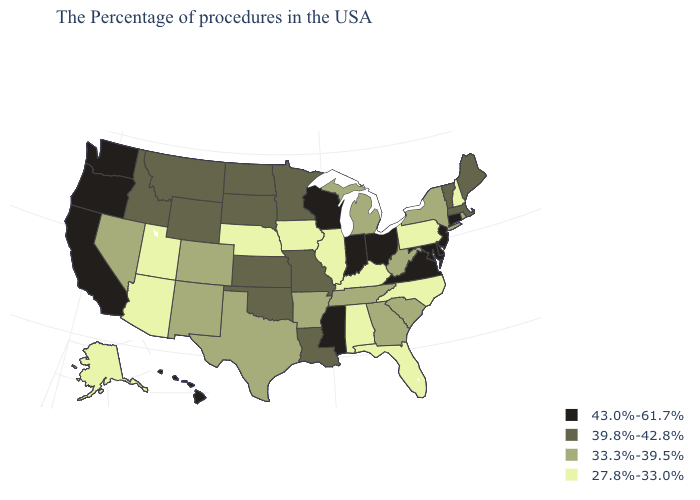What is the lowest value in states that border Arizona?
Write a very short answer. 27.8%-33.0%. What is the value of Rhode Island?
Write a very short answer. 33.3%-39.5%. Does Wisconsin have the highest value in the USA?
Concise answer only. Yes. Does Montana have a lower value than Vermont?
Write a very short answer. No. What is the value of Alaska?
Write a very short answer. 27.8%-33.0%. Name the states that have a value in the range 27.8%-33.0%?
Give a very brief answer. New Hampshire, Pennsylvania, North Carolina, Florida, Kentucky, Alabama, Illinois, Iowa, Nebraska, Utah, Arizona, Alaska. Which states have the lowest value in the USA?
Concise answer only. New Hampshire, Pennsylvania, North Carolina, Florida, Kentucky, Alabama, Illinois, Iowa, Nebraska, Utah, Arizona, Alaska. Does Mississippi have the highest value in the USA?
Concise answer only. Yes. Name the states that have a value in the range 33.3%-39.5%?
Quick response, please. Rhode Island, New York, South Carolina, West Virginia, Georgia, Michigan, Tennessee, Arkansas, Texas, Colorado, New Mexico, Nevada. What is the lowest value in the USA?
Write a very short answer. 27.8%-33.0%. What is the value of Alabama?
Quick response, please. 27.8%-33.0%. Name the states that have a value in the range 27.8%-33.0%?
Give a very brief answer. New Hampshire, Pennsylvania, North Carolina, Florida, Kentucky, Alabama, Illinois, Iowa, Nebraska, Utah, Arizona, Alaska. Name the states that have a value in the range 43.0%-61.7%?
Keep it brief. Connecticut, New Jersey, Delaware, Maryland, Virginia, Ohio, Indiana, Wisconsin, Mississippi, California, Washington, Oregon, Hawaii. Does the map have missing data?
Concise answer only. No. What is the value of New Jersey?
Give a very brief answer. 43.0%-61.7%. 